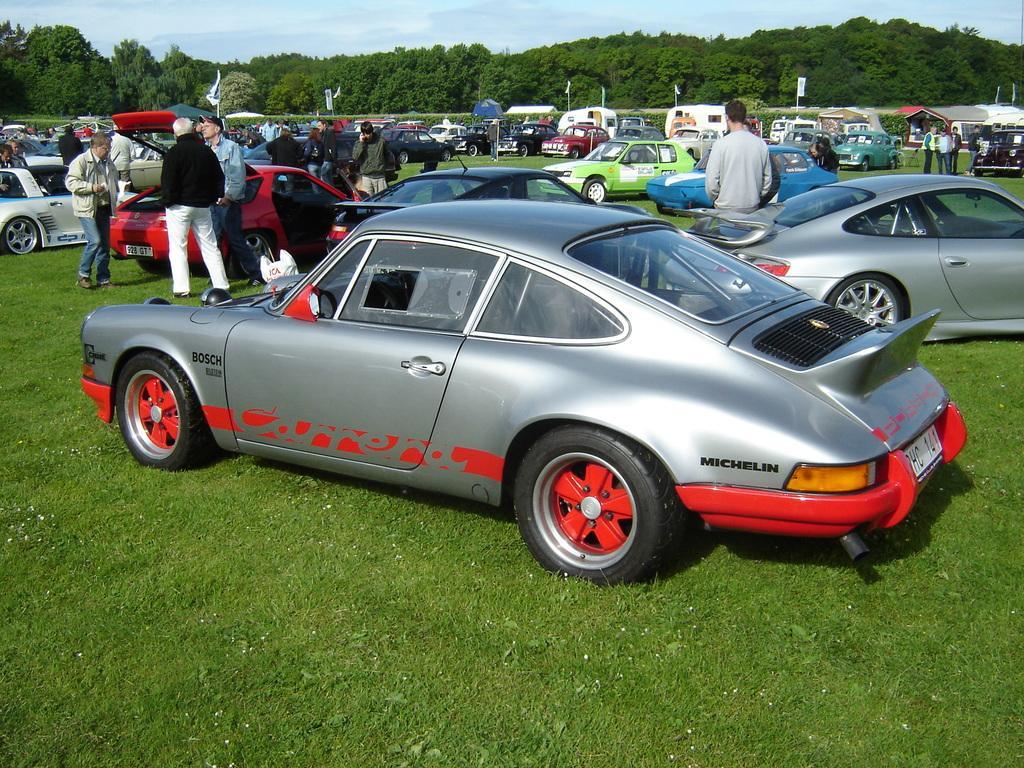Could you give a brief overview of what you see in this image? In this picture I can see many cars on the ground, beside that I can see many persons who are standing. In the back I can see the vans, tents, flags, poles, umbrella and other objects. In the background I can see many trees, plants and grass. At the top I can see the sky and clouds. 